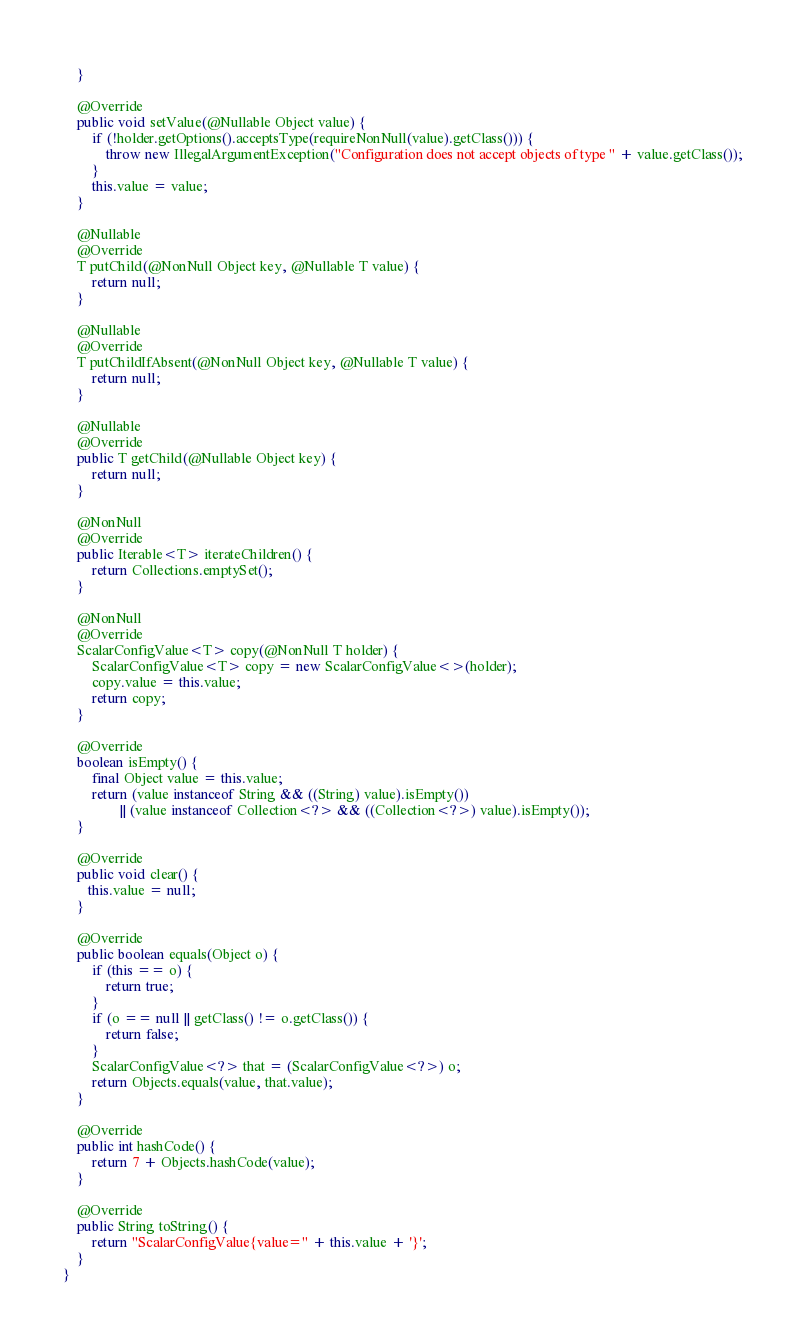Convert code to text. <code><loc_0><loc_0><loc_500><loc_500><_Java_>    }

    @Override
    public void setValue(@Nullable Object value) {
        if (!holder.getOptions().acceptsType(requireNonNull(value).getClass())) {
            throw new IllegalArgumentException("Configuration does not accept objects of type " + value.getClass());
        }
        this.value = value;
    }

    @Nullable
    @Override
    T putChild(@NonNull Object key, @Nullable T value) {
        return null;
    }

    @Nullable
    @Override
    T putChildIfAbsent(@NonNull Object key, @Nullable T value) {
        return null;
    }

    @Nullable
    @Override
    public T getChild(@Nullable Object key) {
        return null;
    }

    @NonNull
    @Override
    public Iterable<T> iterateChildren() {
        return Collections.emptySet();
    }

    @NonNull
    @Override
    ScalarConfigValue<T> copy(@NonNull T holder) {
        ScalarConfigValue<T> copy = new ScalarConfigValue<>(holder);
        copy.value = this.value;
        return copy;
    }

    @Override
    boolean isEmpty() {
        final Object value = this.value;
        return (value instanceof String && ((String) value).isEmpty())
                || (value instanceof Collection<?> && ((Collection<?>) value).isEmpty());
    }

    @Override
    public void clear() {
       this.value = null;
    }

    @Override
    public boolean equals(Object o) {
        if (this == o) {
            return true;
        }
        if (o == null || getClass() != o.getClass()) {
            return false;
        }
        ScalarConfigValue<?> that = (ScalarConfigValue<?>) o;
        return Objects.equals(value, that.value);
    }

    @Override
    public int hashCode() {
        return 7 + Objects.hashCode(value);
    }

    @Override
    public String toString() {
        return "ScalarConfigValue{value=" + this.value + '}';
    }
}
</code> 